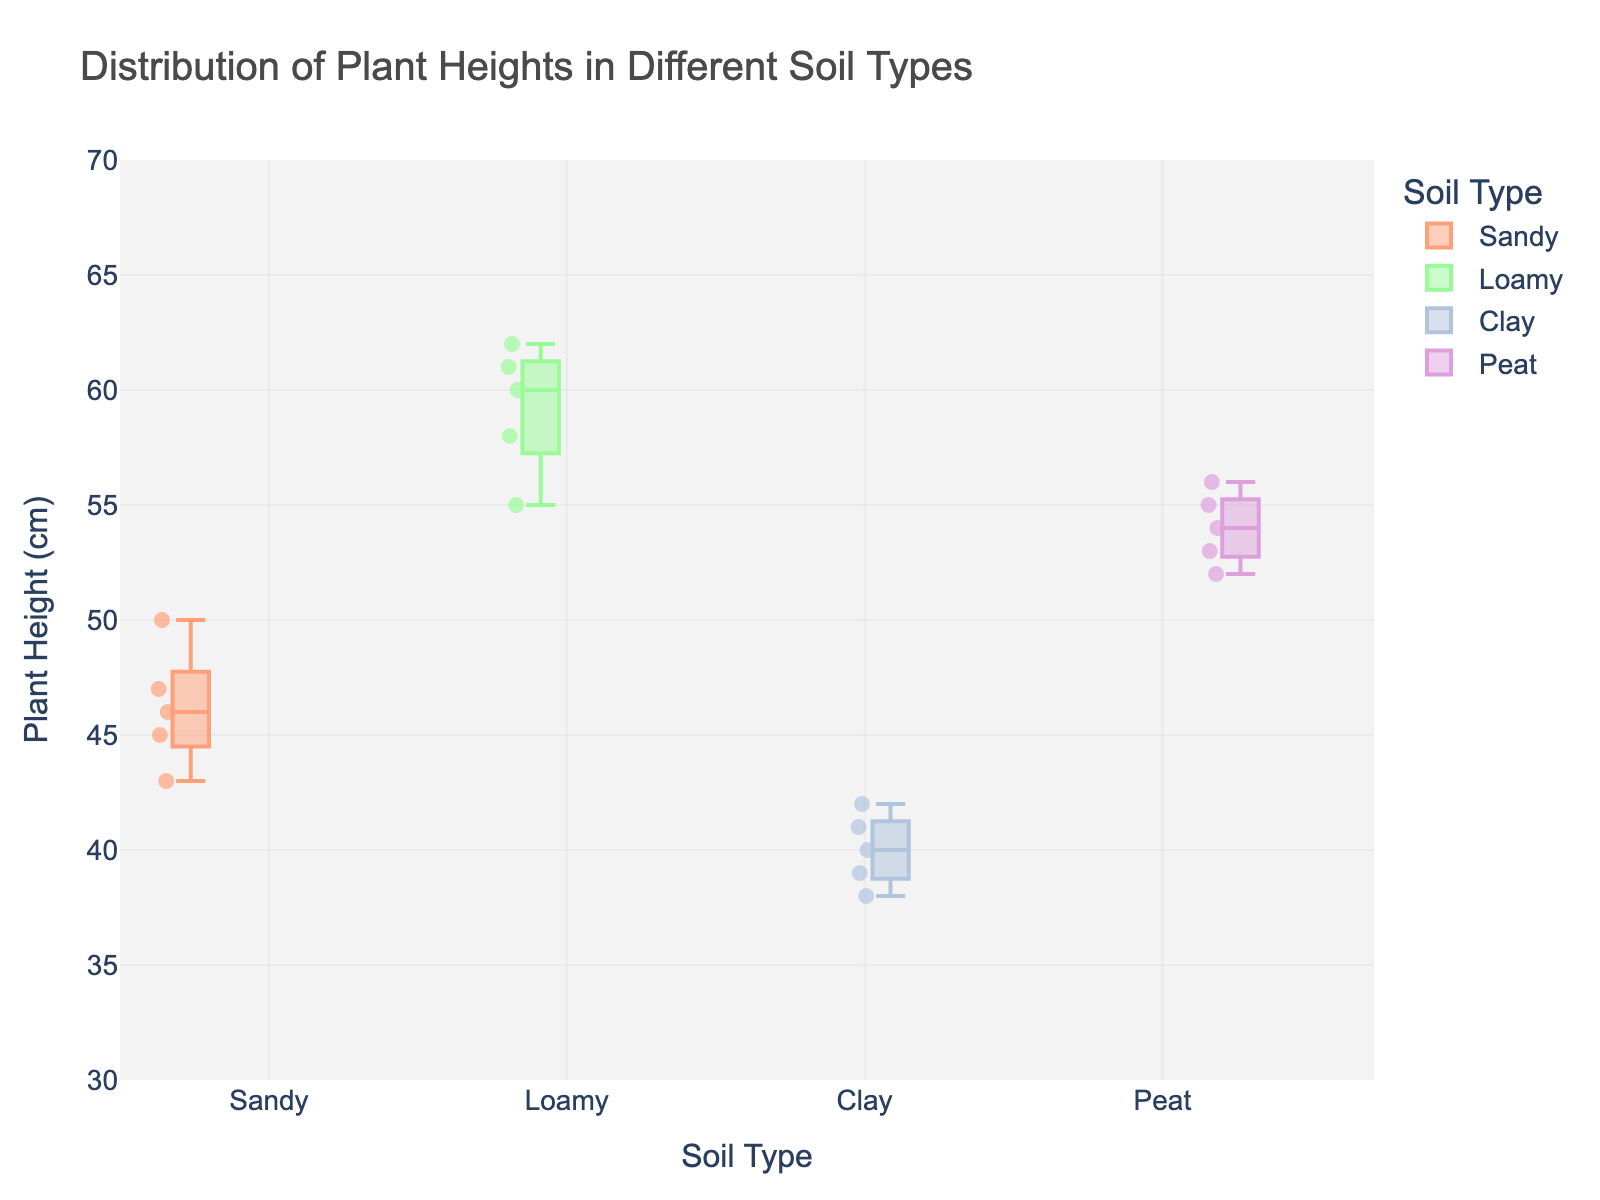What is the title of the box plot? The title of a plot is usually positioned at the top and provides a quick summary of what the plot is about. The title here states clearly what is being analyzed.
Answer: Distribution of Plant Heights in Different Soil Types What is the median plant height for Loamy soil? The box in a box plot represents the interquartile range, and the line inside the box indicates the median of the data set. For Loamy soil, the median is visible as the line inside the green-colored box.
Answer: 60 cm Which soil type has the highest maximum plant height? To determine this, look at the top whisker or the highest point in each box plot. The soil type with the highest whisker or point represents the maximum plant height among the soil types.
Answer: Loamy How many soil types are represented in the box plot? The number of distinct colors and labeled boxes on the x-axis represent different soil types.
Answer: Four Which soil type has the smallest interquartile range (IQR) for plant height? The IQR is represented by the height of the box (from the lower quartile to the upper quartile). The soil type with the smallest box has the smallest IQR.
Answer: Clay What is the range of plant heights for Peat soil? The range is determined by the difference between the smallest and largest whisker (or outlier points if present). Compare the top and bottom whiskers for Peat soil.
Answer: 52 to 56 cm Which soil type has the most variability in plant height? Variability can be inferred from the length of the whiskers and the height of the box. The longer the whiskers and the larger the box, the greater the variability.
Answer: Loamy For which soil type(s) are there data points below the interquartile range? Data points below the interquartile range appear as individual dots outside of the box but within the whisker.
Answer: Sandy What is the approximate median range of plant heights across all soil types? Estimate the median values across all soil types from the center line of each box. Then observe the spread of these median values.
Answer: 40 to 60 cm 